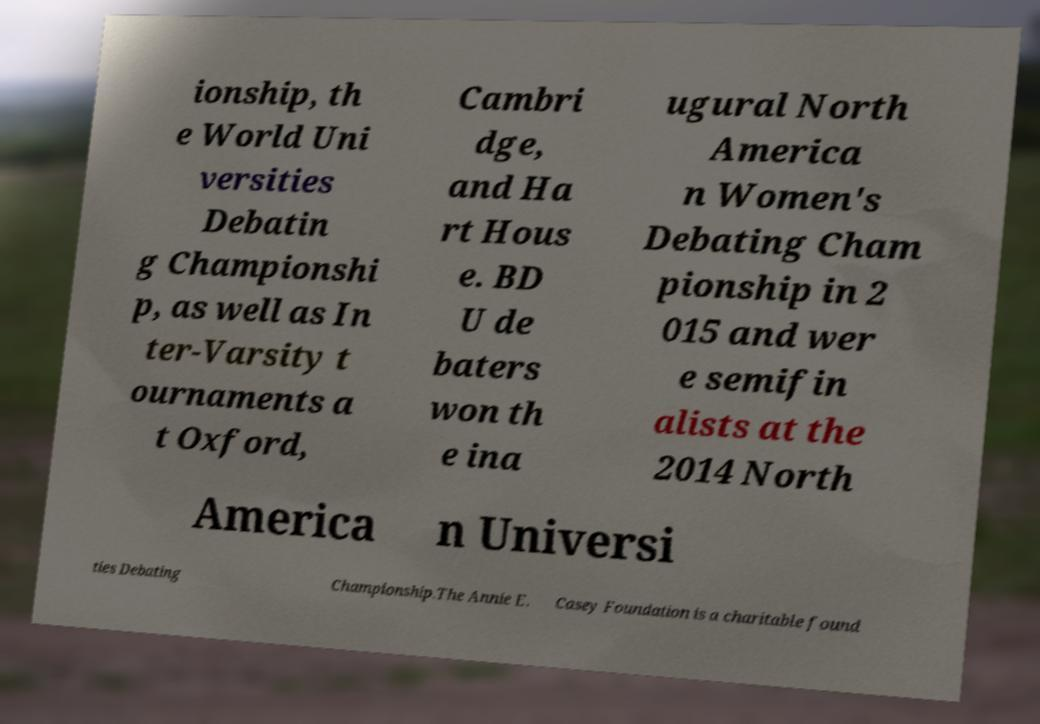Can you read and provide the text displayed in the image?This photo seems to have some interesting text. Can you extract and type it out for me? ionship, th e World Uni versities Debatin g Championshi p, as well as In ter-Varsity t ournaments a t Oxford, Cambri dge, and Ha rt Hous e. BD U de baters won th e ina ugural North America n Women's Debating Cham pionship in 2 015 and wer e semifin alists at the 2014 North America n Universi ties Debating Championship.The Annie E. Casey Foundation is a charitable found 